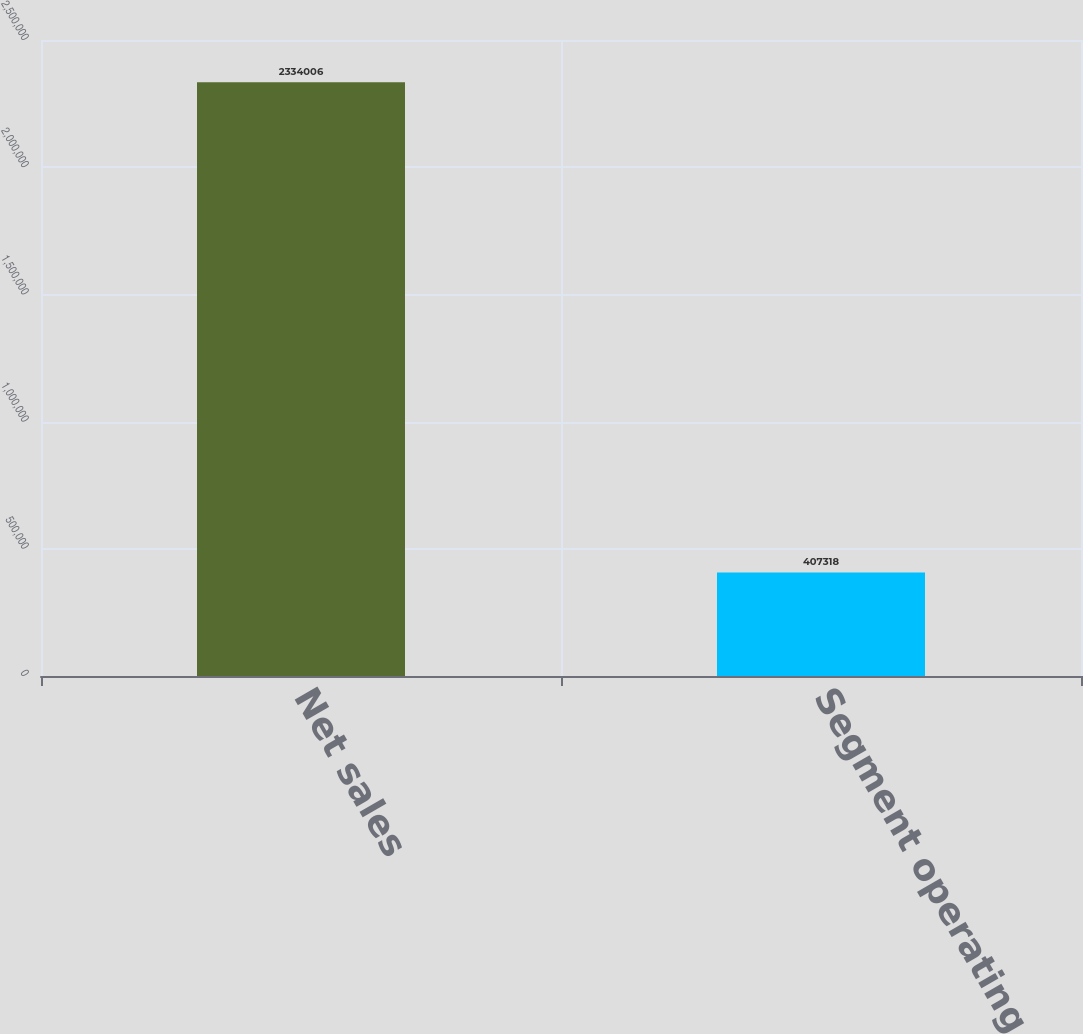<chart> <loc_0><loc_0><loc_500><loc_500><bar_chart><fcel>Net sales<fcel>Segment operating profit<nl><fcel>2.33401e+06<fcel>407318<nl></chart> 